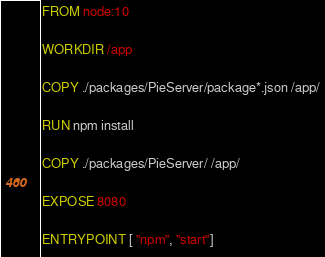Convert code to text. <code><loc_0><loc_0><loc_500><loc_500><_Dockerfile_>FROM node:10

WORKDIR /app

COPY ./packages/PieServer/package*.json /app/

RUN npm install

COPY ./packages/PieServer/ /app/

EXPOSE 8080

ENTRYPOINT [ "npm", "start"]</code> 